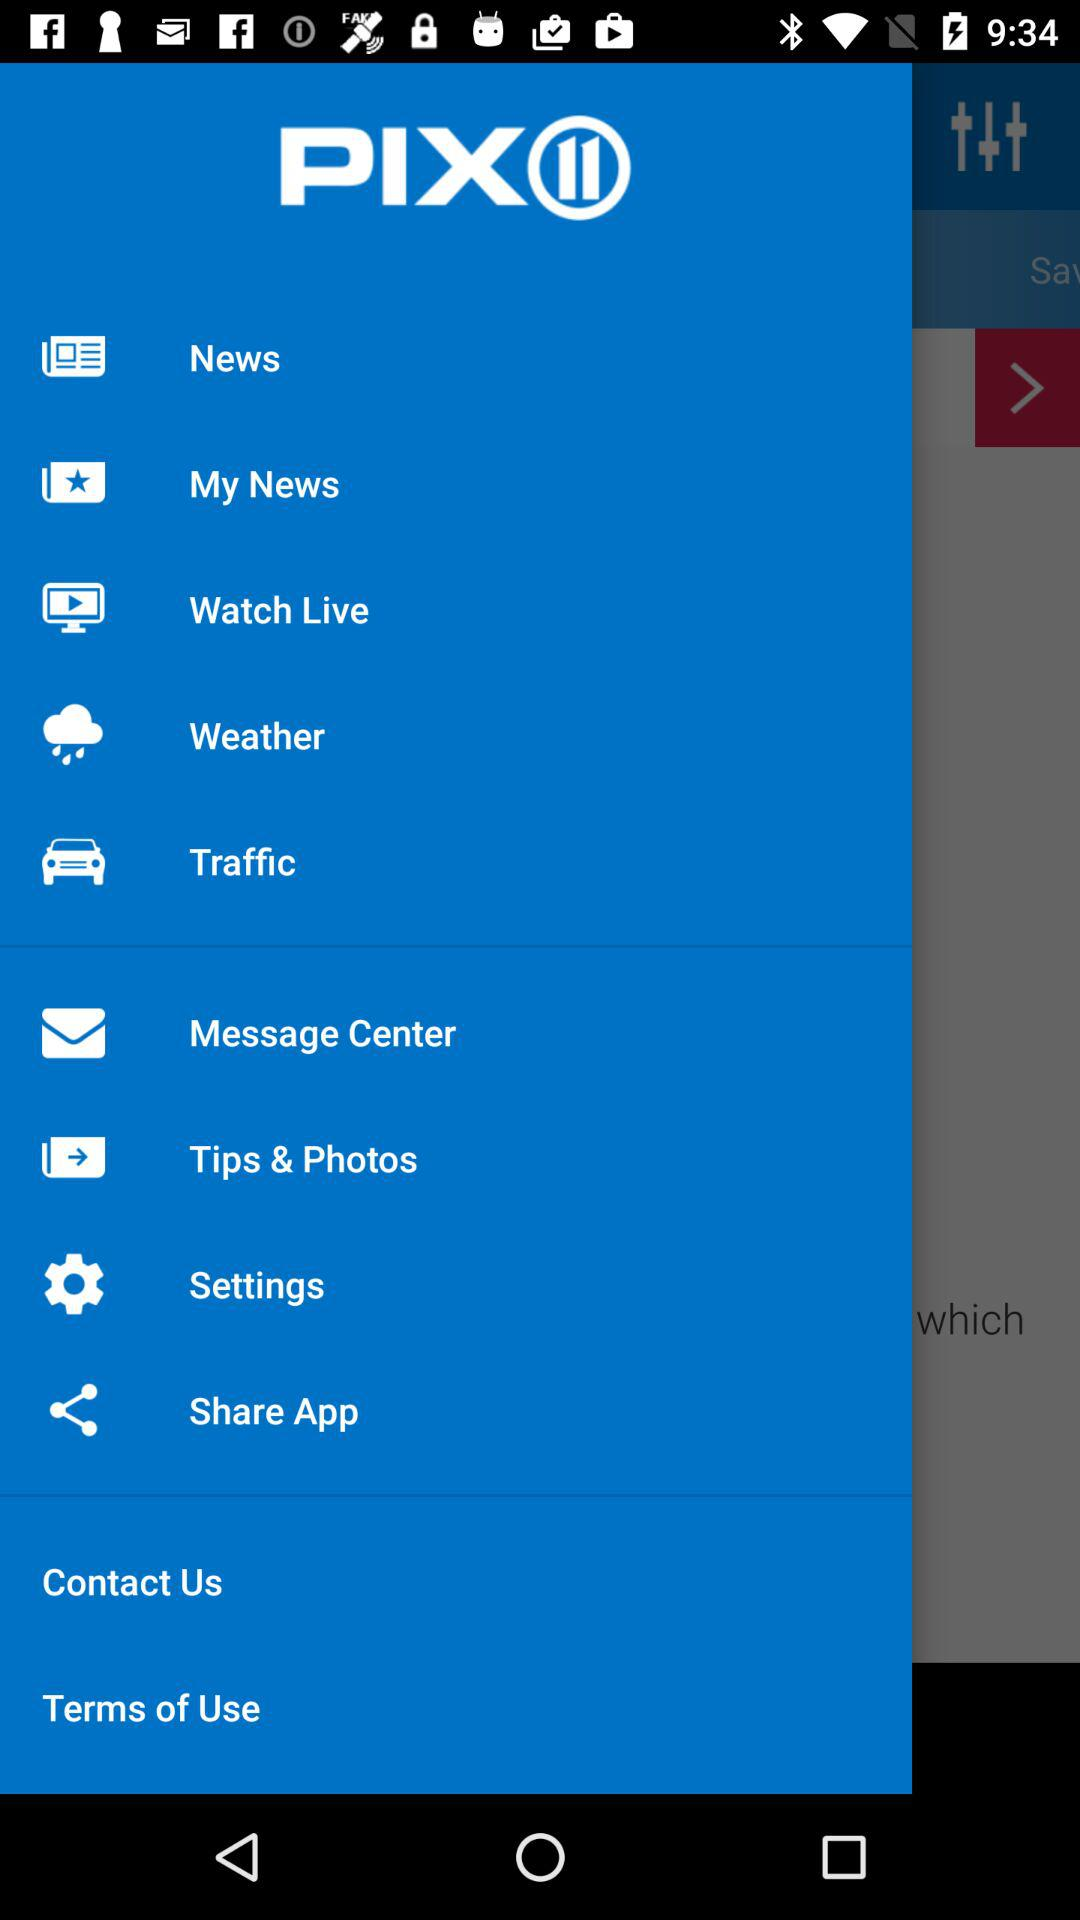How many of the items are labeled 'News'?
Answer the question using a single word or phrase. 2 